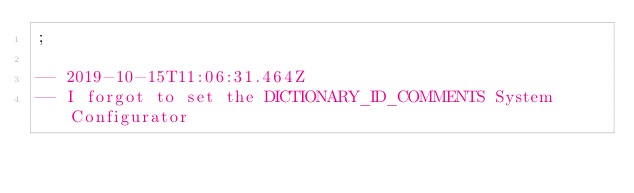<code> <loc_0><loc_0><loc_500><loc_500><_SQL_>;

-- 2019-10-15T11:06:31.464Z
-- I forgot to set the DICTIONARY_ID_COMMENTS System Configurator</code> 